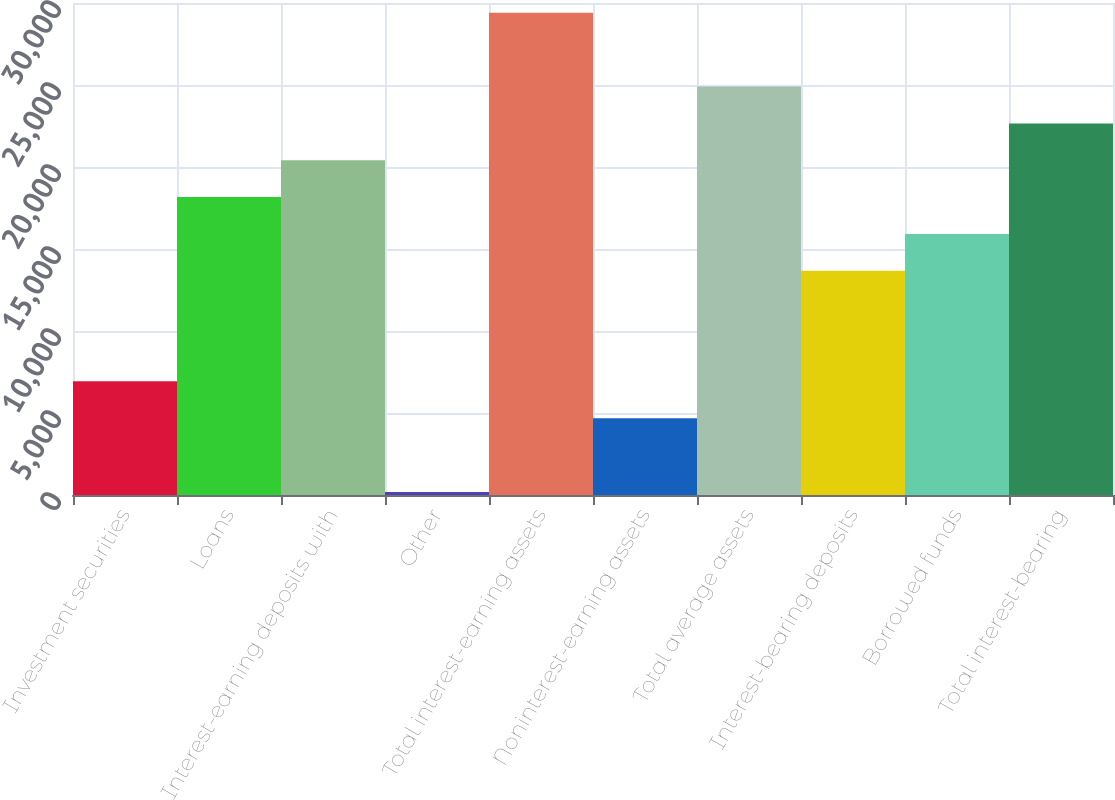<chart> <loc_0><loc_0><loc_500><loc_500><bar_chart><fcel>Investment securities<fcel>Loans<fcel>Interest-earning deposits with<fcel>Other<fcel>Total interest-earning assets<fcel>Noninterest-earning assets<fcel>Total average assets<fcel>Interest-bearing deposits<fcel>Borrowed funds<fcel>Total interest-bearing<nl><fcel>6931<fcel>18166<fcel>20413<fcel>190<fcel>29401<fcel>4684<fcel>24907<fcel>13672<fcel>15919<fcel>22660<nl></chart> 